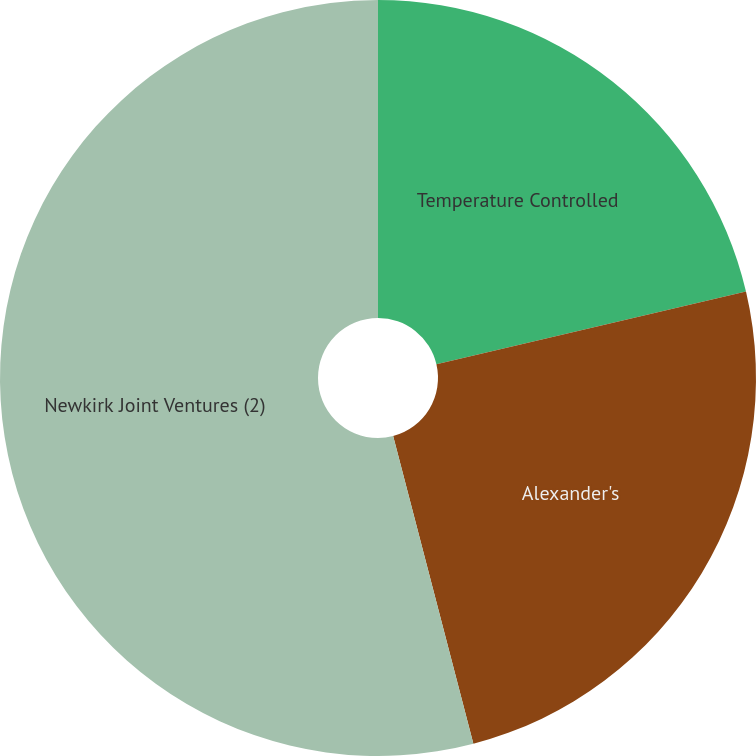Convert chart. <chart><loc_0><loc_0><loc_500><loc_500><pie_chart><fcel>Temperature Controlled<fcel>Alexander's<fcel>Newkirk Joint Ventures (2)<nl><fcel>21.33%<fcel>24.61%<fcel>54.06%<nl></chart> 